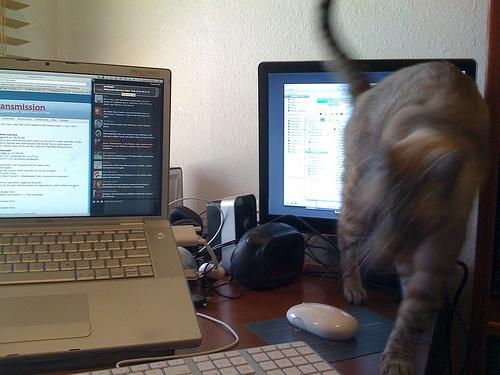Write a concise description of the main focus in the image. A brown, black, and gray cat is walking on a wooden desk amidst various computer equipment and wires. In a brief statement, state the main event taking place in the image. A cat strolls around computer devices and cords scattered on a desk. Describe the primary subject's action in the depicted scene. A cat traverses a cluttered desk strewn with tech gadgets and disordered cords. Create a short scene description focusing on the central subject. A curious cat maneuvers through an array of computer gadgets and tangled cords laid out on a desk. Write a quick summary of the essential activity taking place in the image. A cat weaves through various electronic devices and cord chaos on a desk. Write a brief narrative of the central activity in the image. In an office scene, a bold cat strolls among electronic equipment and cords scattered about a desk. Mention the key object in the image and its activity. The mixed-colored cat is walking on a cluttered desk filled with electronics. In one sentence, describe the main action occurring in the image. A cat roams around a busy desk containing computers, keyboards, and wires. Succinctly point out the focal point of the image and their behavior. An active cat is walking around a workstation full of computer devices and tangled wires. Briefly describe the primary subject and their interaction with the environment. A multi-colored cat explores a workspace cluttered with tech equipment and messy cables. 